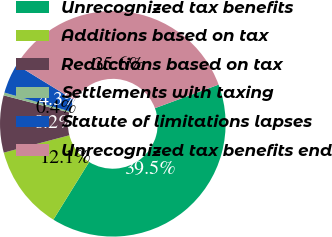<chart> <loc_0><loc_0><loc_500><loc_500><pie_chart><fcel>Unrecognized tax benefits<fcel>Additions based on tax<fcel>Reductions based on tax<fcel>Settlements with taxing<fcel>Statute of limitations lapses<fcel>Unrecognized tax benefits end<nl><fcel>39.47%<fcel>12.05%<fcel>8.17%<fcel>0.41%<fcel>4.29%<fcel>35.6%<nl></chart> 